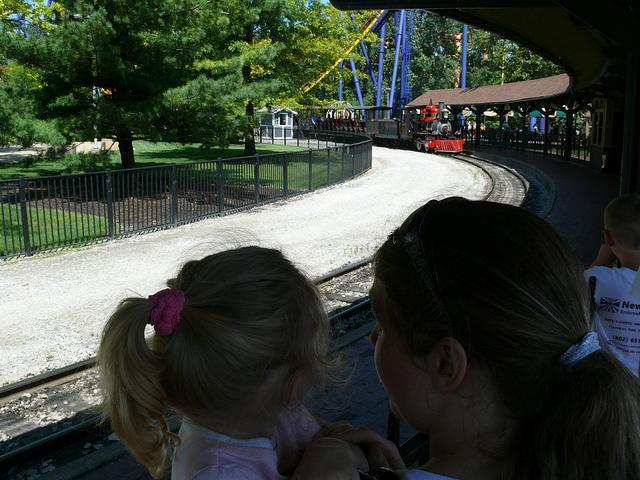How many people can be seen?
Give a very brief answer. 3. 